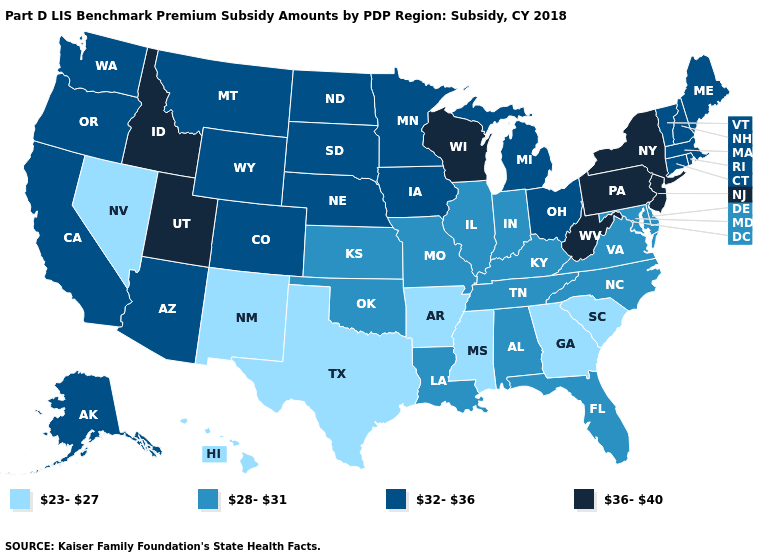What is the lowest value in states that border Illinois?
Be succinct. 28-31. Does Alaska have the highest value in the USA?
Give a very brief answer. No. Name the states that have a value in the range 32-36?
Quick response, please. Alaska, Arizona, California, Colorado, Connecticut, Iowa, Maine, Massachusetts, Michigan, Minnesota, Montana, Nebraska, New Hampshire, North Dakota, Ohio, Oregon, Rhode Island, South Dakota, Vermont, Washington, Wyoming. Does Hawaii have the lowest value in the USA?
Write a very short answer. Yes. Name the states that have a value in the range 32-36?
Write a very short answer. Alaska, Arizona, California, Colorado, Connecticut, Iowa, Maine, Massachusetts, Michigan, Minnesota, Montana, Nebraska, New Hampshire, North Dakota, Ohio, Oregon, Rhode Island, South Dakota, Vermont, Washington, Wyoming. Name the states that have a value in the range 32-36?
Give a very brief answer. Alaska, Arizona, California, Colorado, Connecticut, Iowa, Maine, Massachusetts, Michigan, Minnesota, Montana, Nebraska, New Hampshire, North Dakota, Ohio, Oregon, Rhode Island, South Dakota, Vermont, Washington, Wyoming. What is the lowest value in the South?
Answer briefly. 23-27. What is the value of New Hampshire?
Give a very brief answer. 32-36. What is the value of Delaware?
Be succinct. 28-31. Name the states that have a value in the range 23-27?
Write a very short answer. Arkansas, Georgia, Hawaii, Mississippi, Nevada, New Mexico, South Carolina, Texas. What is the highest value in the USA?
Give a very brief answer. 36-40. What is the value of South Dakota?
Give a very brief answer. 32-36. What is the lowest value in the MidWest?
Write a very short answer. 28-31. What is the value of Montana?
Answer briefly. 32-36. What is the value of Massachusetts?
Be succinct. 32-36. 